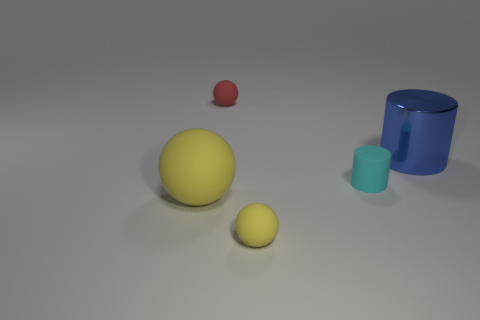Subtract all green cubes. How many yellow balls are left? 2 Add 1 large yellow things. How many objects exist? 6 Subtract all cylinders. How many objects are left? 3 Subtract all red rubber objects. Subtract all yellow spheres. How many objects are left? 2 Add 1 cyan rubber cylinders. How many cyan rubber cylinders are left? 2 Add 1 big metal blocks. How many big metal blocks exist? 1 Subtract 0 gray balls. How many objects are left? 5 